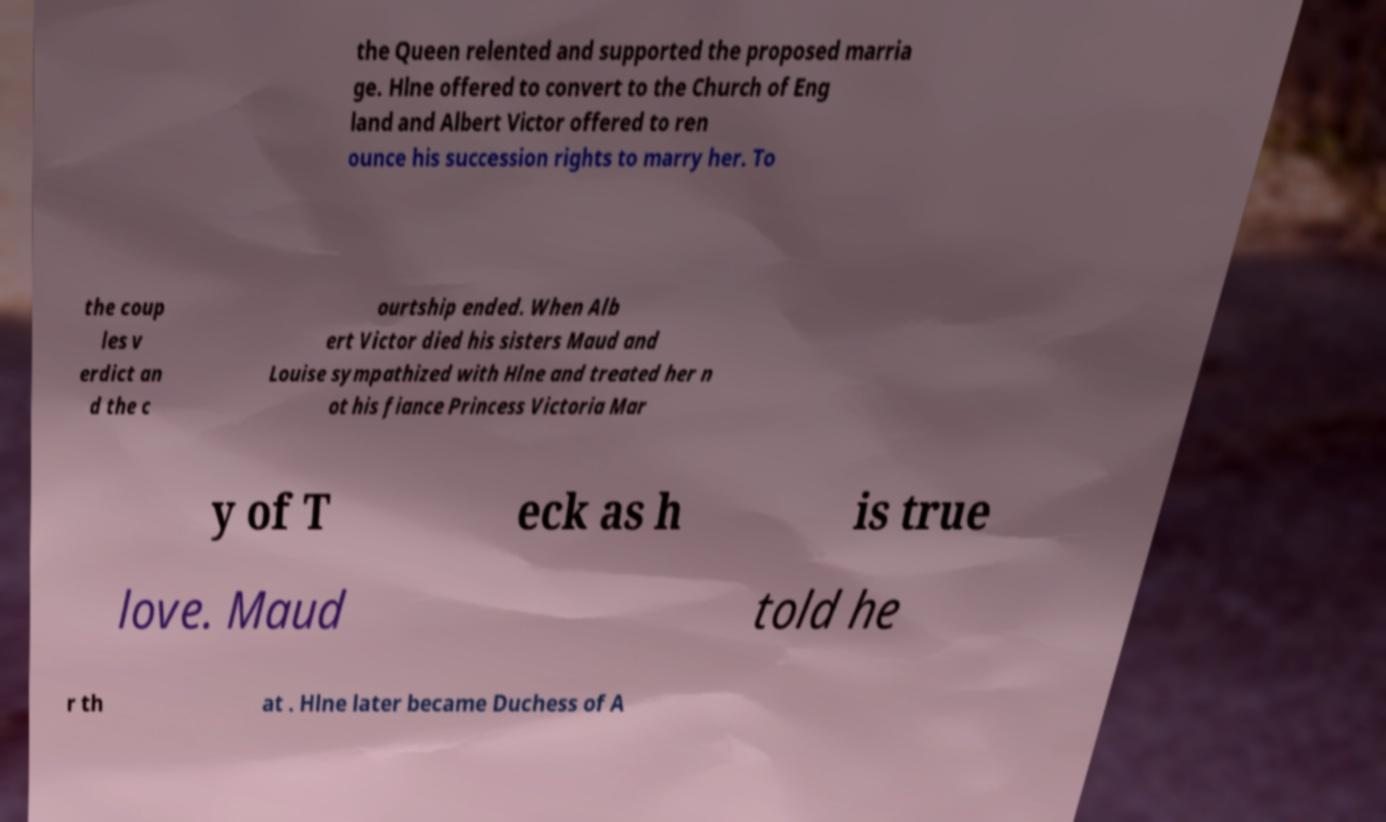For documentation purposes, I need the text within this image transcribed. Could you provide that? the Queen relented and supported the proposed marria ge. Hlne offered to convert to the Church of Eng land and Albert Victor offered to ren ounce his succession rights to marry her. To the coup les v erdict an d the c ourtship ended. When Alb ert Victor died his sisters Maud and Louise sympathized with Hlne and treated her n ot his fiance Princess Victoria Mar y of T eck as h is true love. Maud told he r th at . Hlne later became Duchess of A 